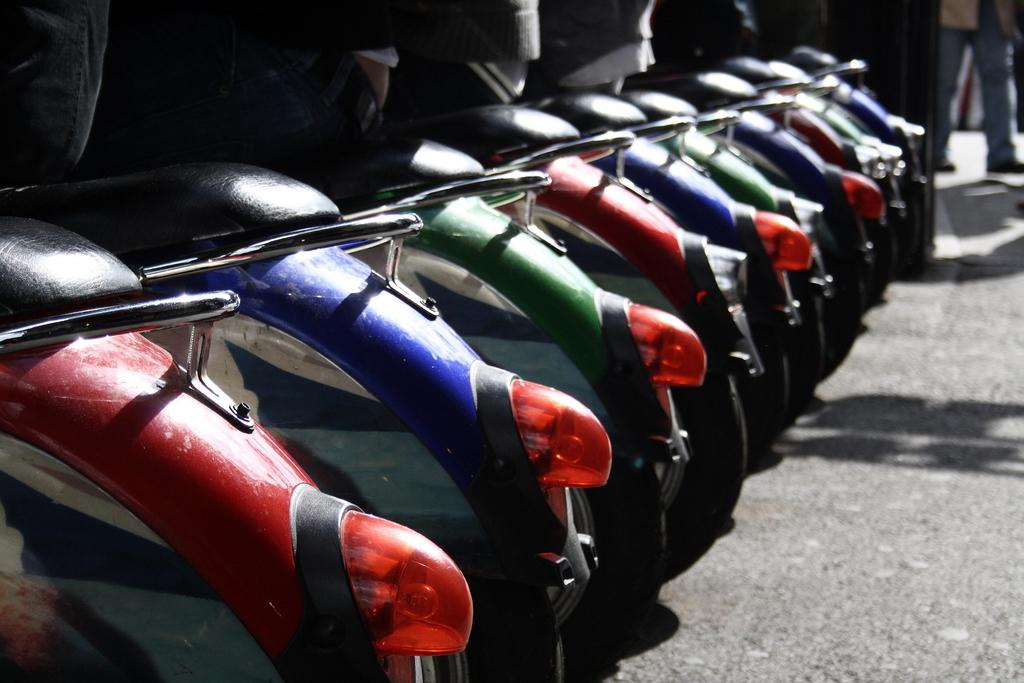What type of vehicles are on the road in the image? There are bikes on the road in the image. Can you describe the person in the background of the image? There is a person in the background of the image, but their specific appearance or actions are not discernible. What type of fruit is being transported in the cart in the image? There is no cart present in the image, and therefore no fruit being transported. Can you tell me how many streams are visible in the image? There are no streams visible in the image. 